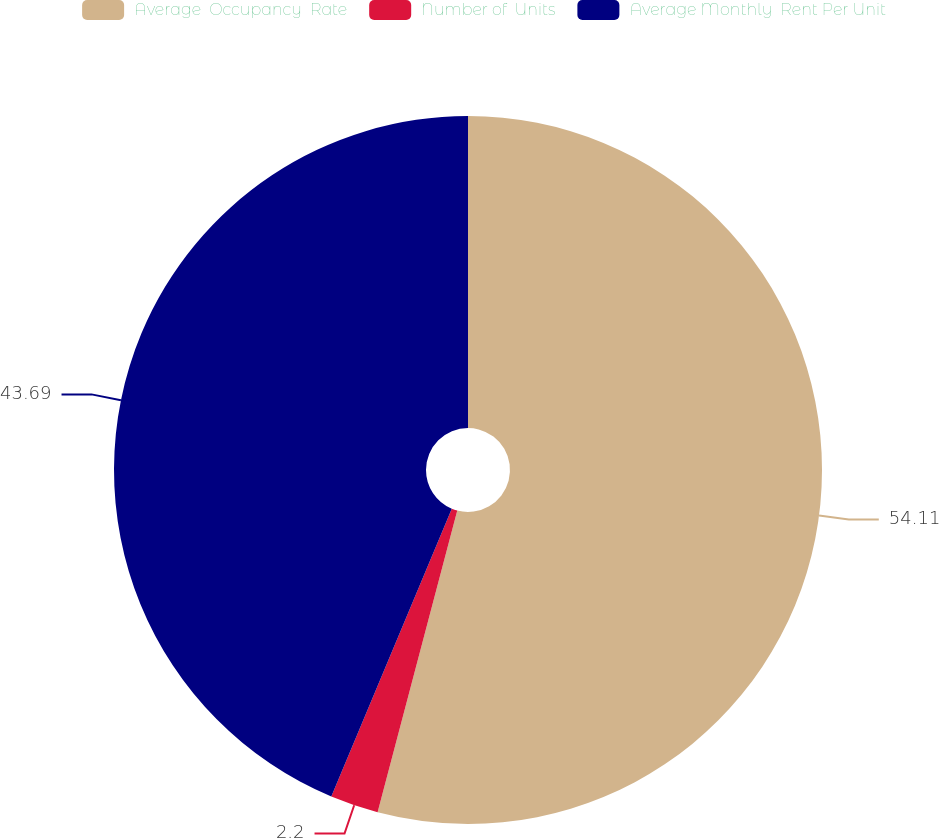Convert chart. <chart><loc_0><loc_0><loc_500><loc_500><pie_chart><fcel>Average  Occupancy  Rate<fcel>Number of  Units<fcel>Average Monthly  Rent Per Unit<nl><fcel>54.11%<fcel>2.2%<fcel>43.69%<nl></chart> 